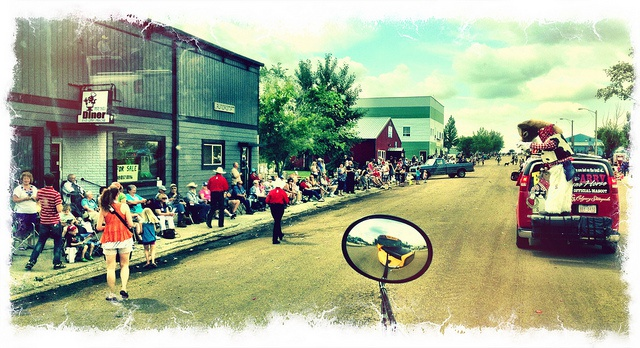Describe the objects in this image and their specific colors. I can see people in white, black, khaki, gray, and teal tones, car in white, black, maroon, navy, and brown tones, people in white, khaki, black, lightyellow, and gray tones, people in white, khaki, black, tan, and salmon tones, and people in white, black, navy, brown, and tan tones in this image. 